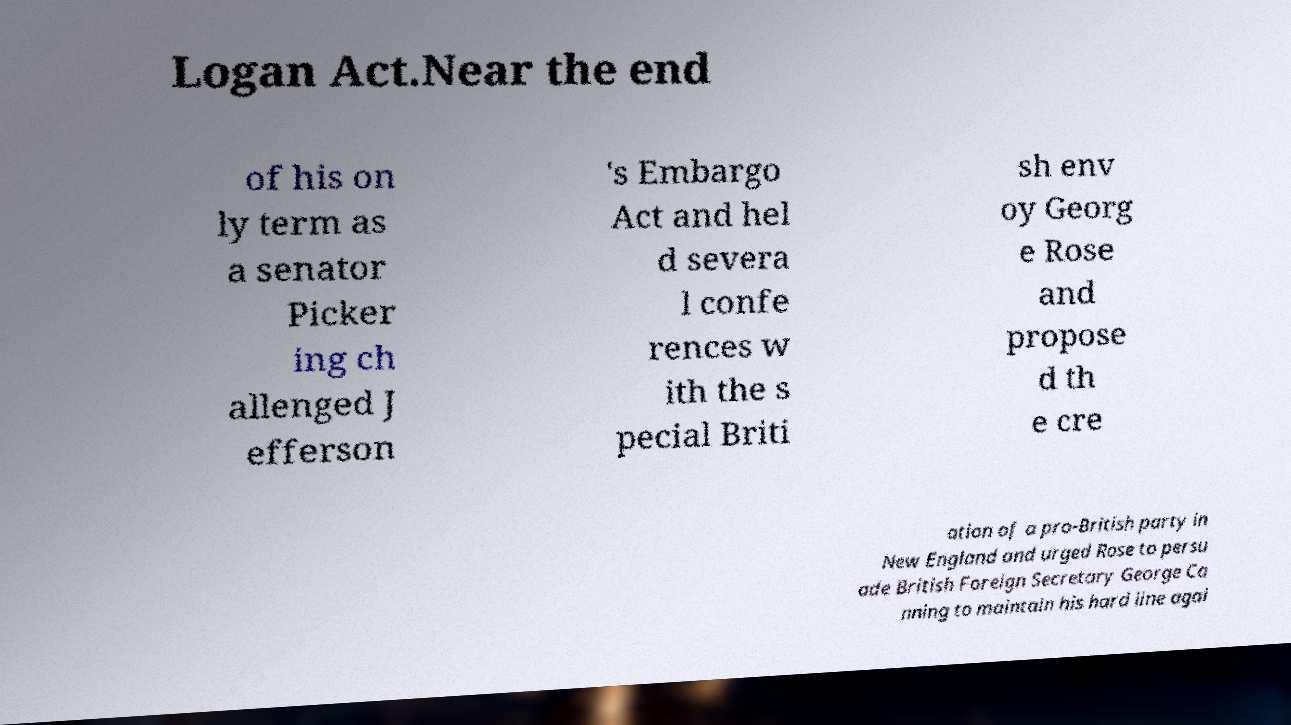I need the written content from this picture converted into text. Can you do that? Logan Act.Near the end of his on ly term as a senator Picker ing ch allenged J efferson 's Embargo Act and hel d severa l confe rences w ith the s pecial Briti sh env oy Georg e Rose and propose d th e cre ation of a pro-British party in New England and urged Rose to persu ade British Foreign Secretary George Ca nning to maintain his hard line agai 